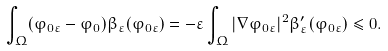<formula> <loc_0><loc_0><loc_500><loc_500>\int _ { \Omega } ( \varphi _ { 0 \varepsilon } - \varphi _ { 0 } ) \beta _ { \varepsilon } ( \varphi _ { 0 \varepsilon } ) = - \varepsilon \int _ { \Omega } | \nabla \varphi _ { 0 \varepsilon } | ^ { 2 } \beta ^ { \prime } _ { \varepsilon } ( \varphi _ { 0 \varepsilon } ) \leq 0 .</formula> 